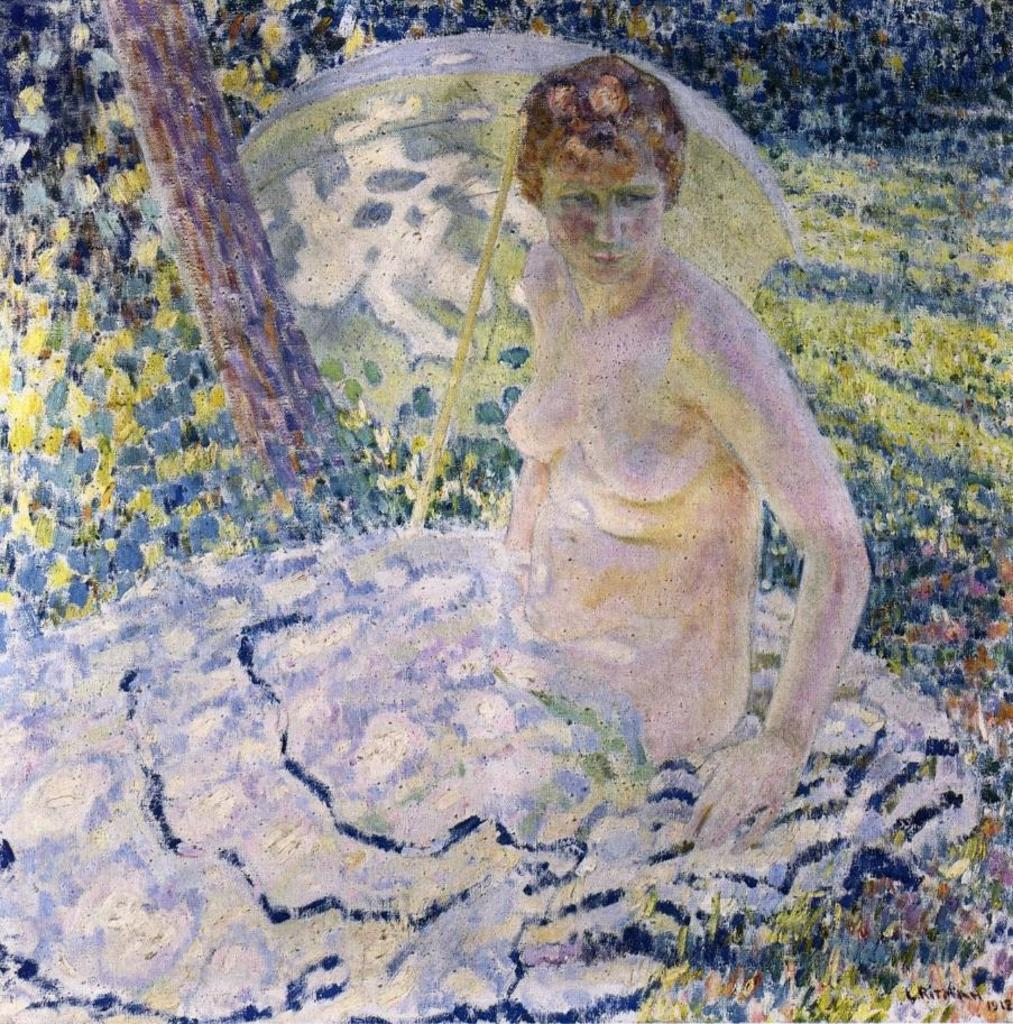What type of artwork is depicted in the image? The image is a painting. Can you describe the subject of the painting? There is a person in the painting. What object is the person holding in the painting? There is an umbrella in the painting. What natural element is present in the painting? There is a tree trunk in the painting. What can be seen in the background of the painting? There is greenery in the background of the painting. Is there any text visible in the painting? Yes, there is some text visible in the bottom right of the painting. What type of gate can be seen in the painting? There is no gate present in the painting; it features a person, umbrella, tree trunk, greenery, and text. Can you describe the manager's role in the painting? There is no manager depicted in the painting; it only features a person, umbrella, tree trunk, greenery, and text. 